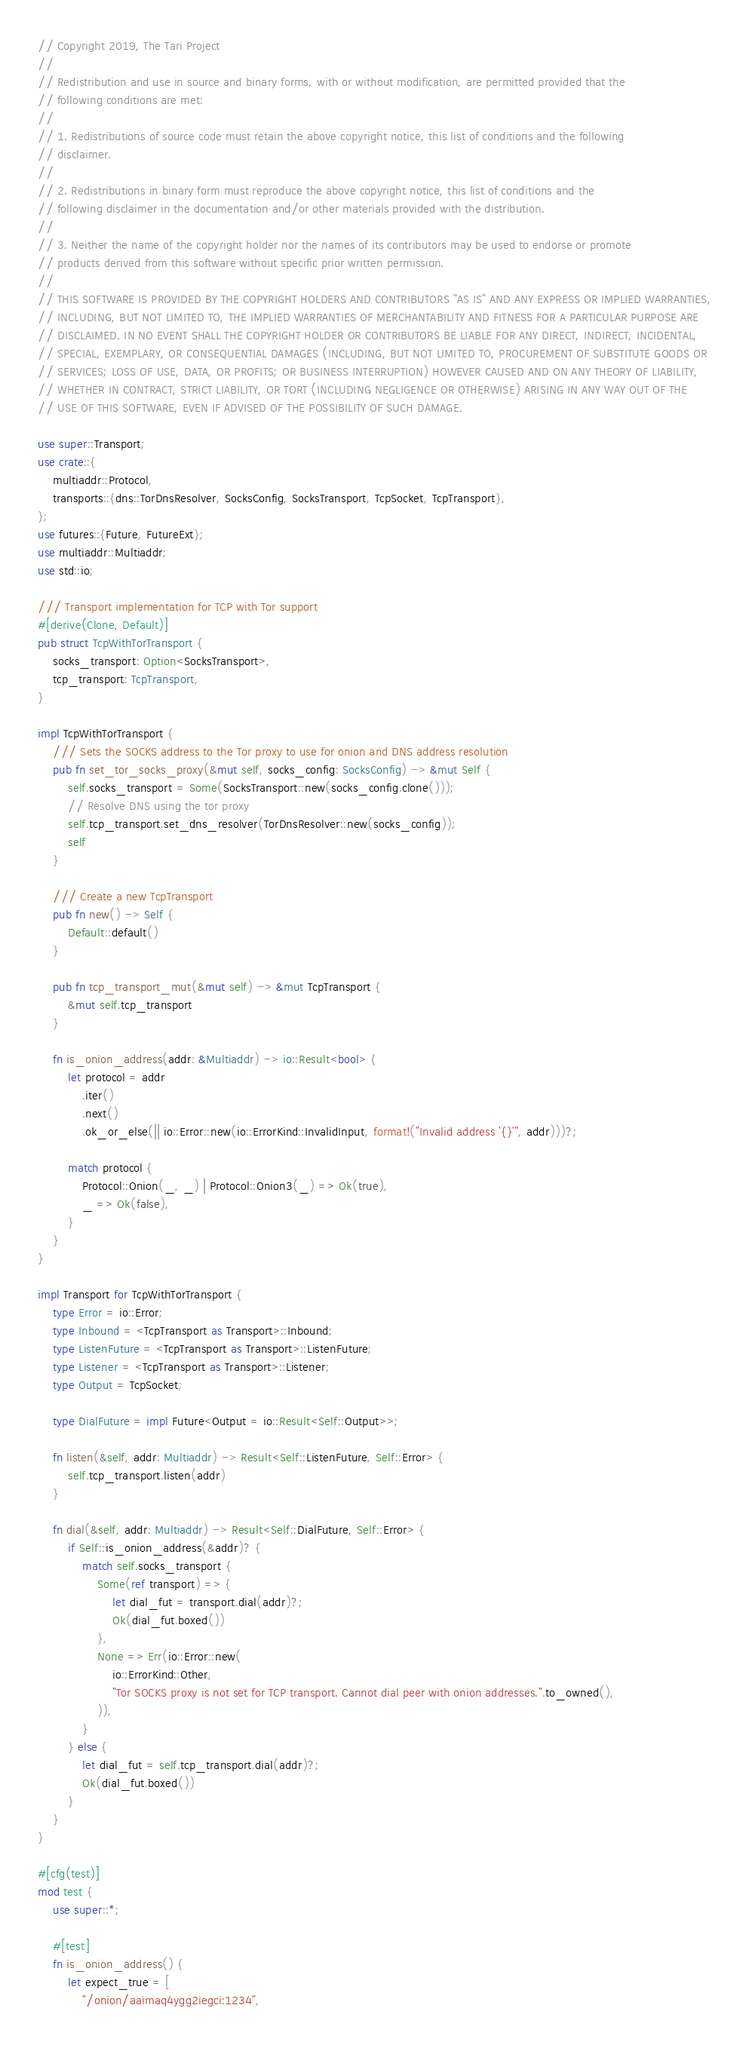Convert code to text. <code><loc_0><loc_0><loc_500><loc_500><_Rust_>// Copyright 2019, The Tari Project
//
// Redistribution and use in source and binary forms, with or without modification, are permitted provided that the
// following conditions are met:
//
// 1. Redistributions of source code must retain the above copyright notice, this list of conditions and the following
// disclaimer.
//
// 2. Redistributions in binary form must reproduce the above copyright notice, this list of conditions and the
// following disclaimer in the documentation and/or other materials provided with the distribution.
//
// 3. Neither the name of the copyright holder nor the names of its contributors may be used to endorse or promote
// products derived from this software without specific prior written permission.
//
// THIS SOFTWARE IS PROVIDED BY THE COPYRIGHT HOLDERS AND CONTRIBUTORS "AS IS" AND ANY EXPRESS OR IMPLIED WARRANTIES,
// INCLUDING, BUT NOT LIMITED TO, THE IMPLIED WARRANTIES OF MERCHANTABILITY AND FITNESS FOR A PARTICULAR PURPOSE ARE
// DISCLAIMED. IN NO EVENT SHALL THE COPYRIGHT HOLDER OR CONTRIBUTORS BE LIABLE FOR ANY DIRECT, INDIRECT, INCIDENTAL,
// SPECIAL, EXEMPLARY, OR CONSEQUENTIAL DAMAGES (INCLUDING, BUT NOT LIMITED TO, PROCUREMENT OF SUBSTITUTE GOODS OR
// SERVICES; LOSS OF USE, DATA, OR PROFITS; OR BUSINESS INTERRUPTION) HOWEVER CAUSED AND ON ANY THEORY OF LIABILITY,
// WHETHER IN CONTRACT, STRICT LIABILITY, OR TORT (INCLUDING NEGLIGENCE OR OTHERWISE) ARISING IN ANY WAY OUT OF THE
// USE OF THIS SOFTWARE, EVEN IF ADVISED OF THE POSSIBILITY OF SUCH DAMAGE.

use super::Transport;
use crate::{
    multiaddr::Protocol,
    transports::{dns::TorDnsResolver, SocksConfig, SocksTransport, TcpSocket, TcpTransport},
};
use futures::{Future, FutureExt};
use multiaddr::Multiaddr;
use std::io;

/// Transport implementation for TCP with Tor support
#[derive(Clone, Default)]
pub struct TcpWithTorTransport {
    socks_transport: Option<SocksTransport>,
    tcp_transport: TcpTransport,
}

impl TcpWithTorTransport {
    /// Sets the SOCKS address to the Tor proxy to use for onion and DNS address resolution
    pub fn set_tor_socks_proxy(&mut self, socks_config: SocksConfig) -> &mut Self {
        self.socks_transport = Some(SocksTransport::new(socks_config.clone()));
        // Resolve DNS using the tor proxy
        self.tcp_transport.set_dns_resolver(TorDnsResolver::new(socks_config));
        self
    }

    /// Create a new TcpTransport
    pub fn new() -> Self {
        Default::default()
    }

    pub fn tcp_transport_mut(&mut self) -> &mut TcpTransport {
        &mut self.tcp_transport
    }

    fn is_onion_address(addr: &Multiaddr) -> io::Result<bool> {
        let protocol = addr
            .iter()
            .next()
            .ok_or_else(|| io::Error::new(io::ErrorKind::InvalidInput, format!("Invalid address '{}'", addr)))?;

        match protocol {
            Protocol::Onion(_, _) | Protocol::Onion3(_) => Ok(true),
            _ => Ok(false),
        }
    }
}

impl Transport for TcpWithTorTransport {
    type Error = io::Error;
    type Inbound = <TcpTransport as Transport>::Inbound;
    type ListenFuture = <TcpTransport as Transport>::ListenFuture;
    type Listener = <TcpTransport as Transport>::Listener;
    type Output = TcpSocket;

    type DialFuture = impl Future<Output = io::Result<Self::Output>>;

    fn listen(&self, addr: Multiaddr) -> Result<Self::ListenFuture, Self::Error> {
        self.tcp_transport.listen(addr)
    }

    fn dial(&self, addr: Multiaddr) -> Result<Self::DialFuture, Self::Error> {
        if Self::is_onion_address(&addr)? {
            match self.socks_transport {
                Some(ref transport) => {
                    let dial_fut = transport.dial(addr)?;
                    Ok(dial_fut.boxed())
                },
                None => Err(io::Error::new(
                    io::ErrorKind::Other,
                    "Tor SOCKS proxy is not set for TCP transport. Cannot dial peer with onion addresses.".to_owned(),
                )),
            }
        } else {
            let dial_fut = self.tcp_transport.dial(addr)?;
            Ok(dial_fut.boxed())
        }
    }
}

#[cfg(test)]
mod test {
    use super::*;

    #[test]
    fn is_onion_address() {
        let expect_true = [
            "/onion/aaimaq4ygg2iegci:1234",</code> 